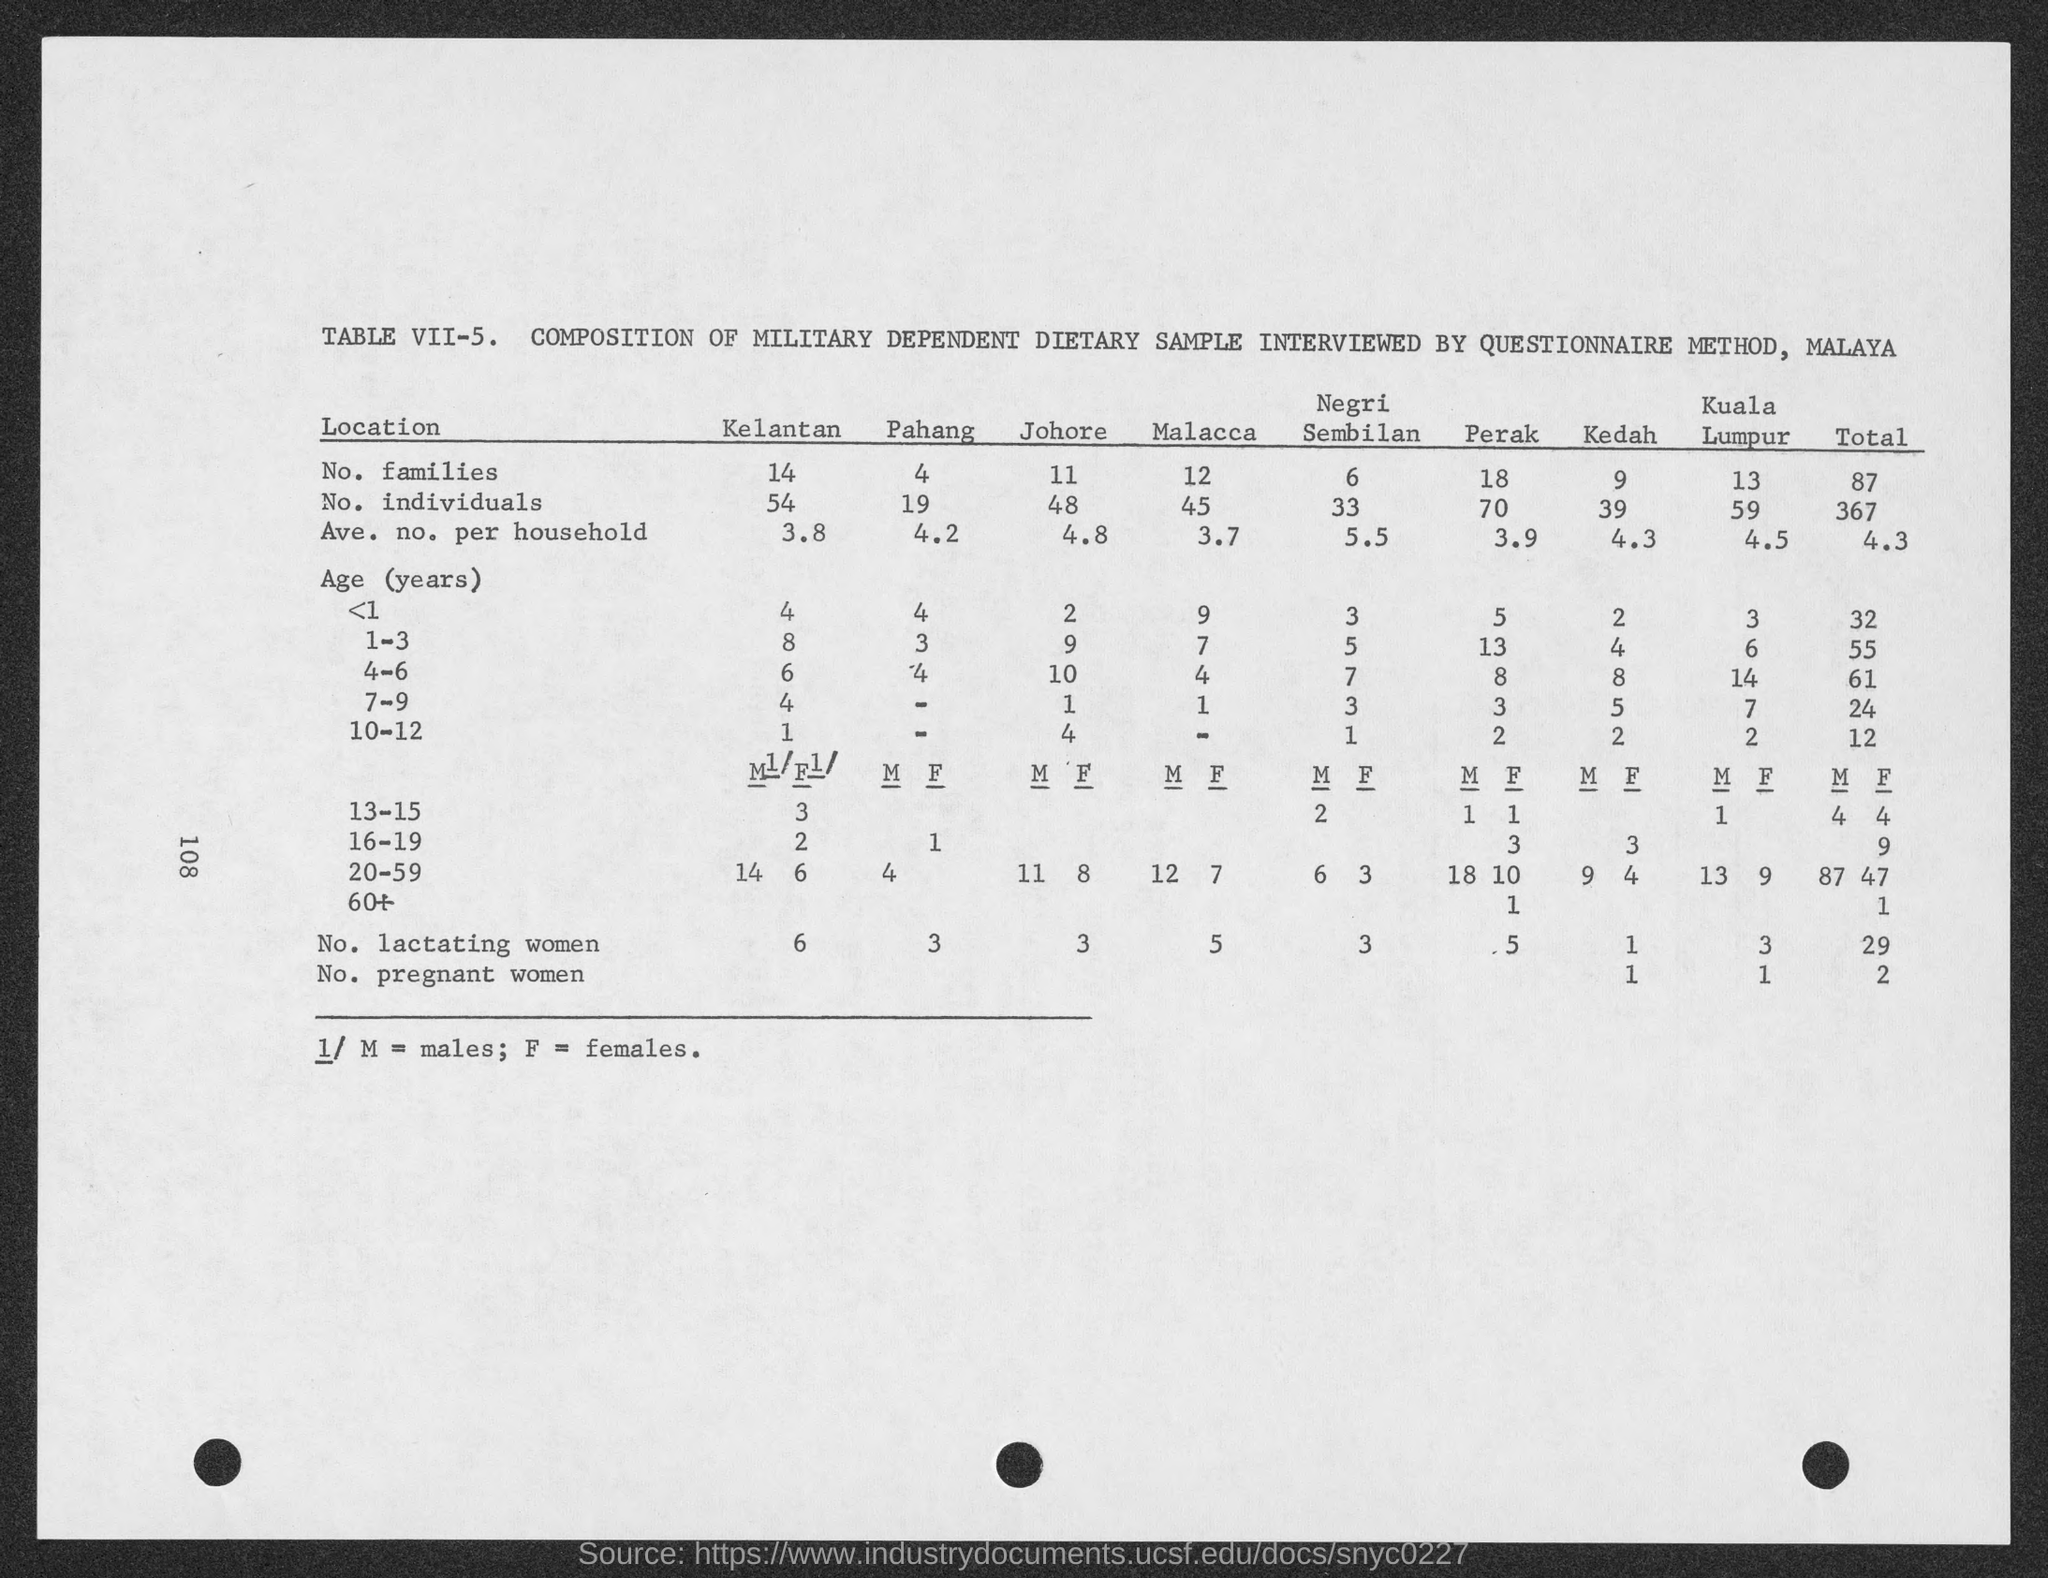Point out several critical features in this image. There are 4 families in Pahang. There are 13 families in Kuala Lumpur. There are 18 families in Perak. There are 12 families in Malacca. Kedah has 9 families. 